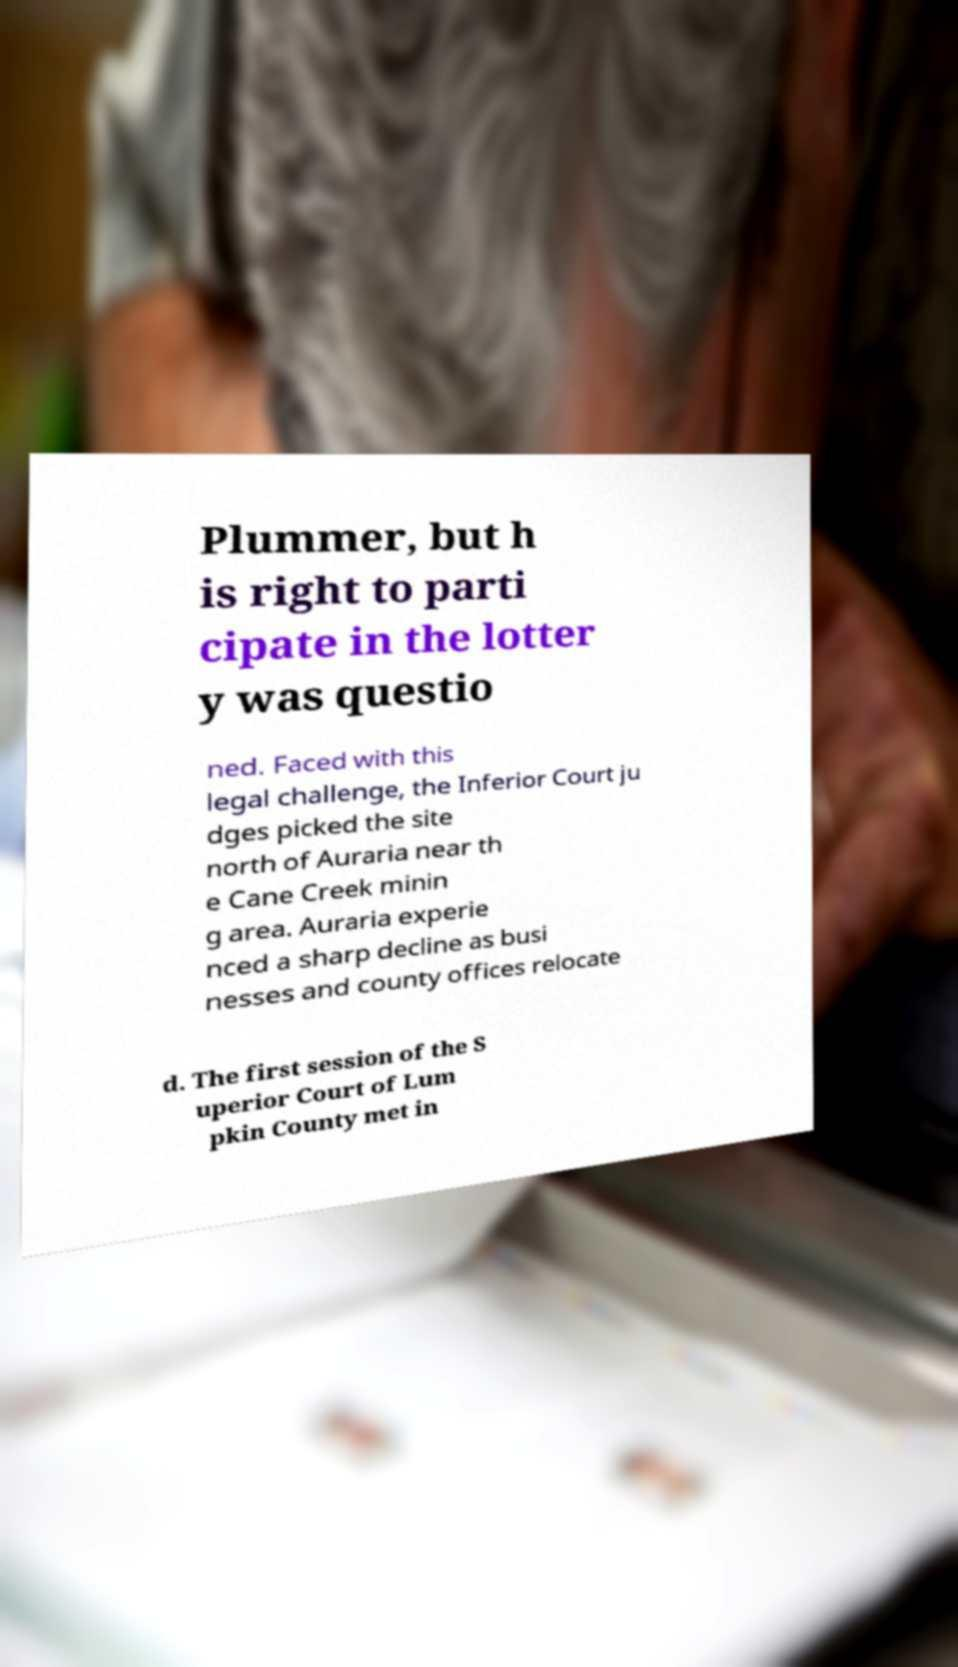Please read and relay the text visible in this image. What does it say? Plummer, but h is right to parti cipate in the lotter y was questio ned. Faced with this legal challenge, the Inferior Court ju dges picked the site north of Auraria near th e Cane Creek minin g area. Auraria experie nced a sharp decline as busi nesses and county offices relocate d. The first session of the S uperior Court of Lum pkin County met in 